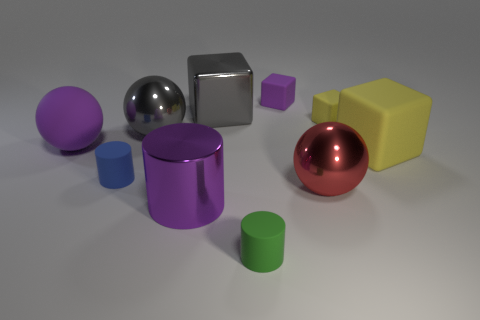Are there any red objects of the same size as the purple metallic cylinder?
Provide a succinct answer. Yes. There is a tiny thing that is the same color as the large matte block; what shape is it?
Ensure brevity in your answer.  Cube. What number of metallic cylinders are the same size as the gray shiny ball?
Your answer should be compact. 1. Does the shiny ball that is in front of the big rubber ball have the same size as the purple matte thing to the right of the gray metallic block?
Provide a short and direct response. No. What number of objects are either yellow matte objects or yellow matte blocks behind the big purple matte sphere?
Provide a short and direct response. 2. The big metal cube is what color?
Your answer should be compact. Gray. What is the material of the purple object that is behind the large purple thing left of the tiny rubber thing left of the large purple cylinder?
Offer a terse response. Rubber. There is a cylinder that is made of the same material as the small blue thing; what size is it?
Your answer should be compact. Small. Is there a small cube of the same color as the big metallic cylinder?
Offer a very short reply. Yes. There is a gray metallic block; does it have the same size as the matte cylinder behind the big purple metal cylinder?
Your answer should be very brief. No. 